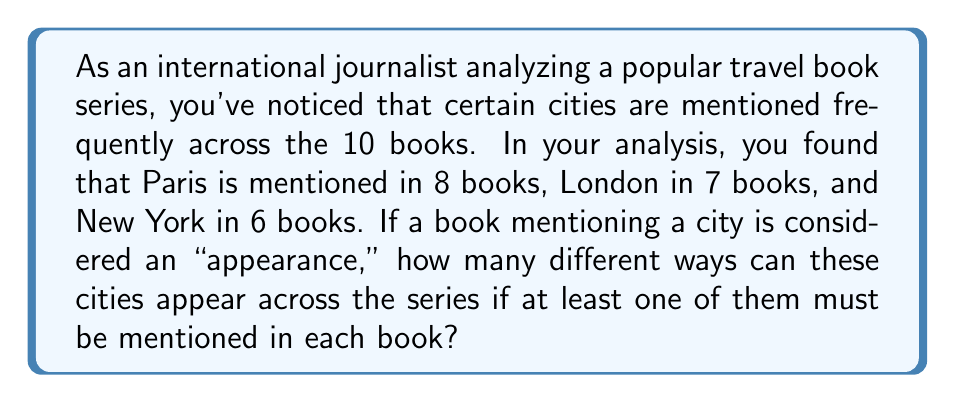Solve this math problem. Let's approach this step-by-step using the Inclusion-Exclusion Principle:

1) First, let's define our sets:
   P: Books mentioning Paris
   L: Books mentioning London
   N: Books mentioning New York

2) We want to find $|P \cup L \cup N|$, but we need to subtract the total number of books (10) from this to get the number of different ways the cities can appear.

3) Using the Inclusion-Exclusion Principle:

   $$|P \cup L \cup N| = |P| + |L| + |N| - |P \cap L| - |P \cap N| - |L \cap N| + |P \cap L \cap N|$$

4) We know $|P| = 8$, $|L| = 7$, and $|N| = 6$.

5) To find the intersections, we can use the complement method:
   $|P \cap L| = |P| + |L| - |P \cup L| = 8 + 7 - 10 = 5$
   $|P \cap N| = |P| + |N| - |P \cup N| = 8 + 6 - 10 = 4$
   $|L \cap N| = |L| + |N| - |L \cup N| = 7 + 6 - 10 = 3$

6) For $|P \cap L \cap N|$, we can use:
   $|P \cap L \cap N| = |P| + |L| + |N| - |P \cup L| - |P \cup N| - |L \cup N| + |P \cup L \cup N|$
   $= 8 + 7 + 6 - 10 - 10 - 10 + 10 = 1$

7) Now we can substitute these values:

   $$|P \cup L \cup N| = 8 + 7 + 6 - 5 - 4 - 3 + 1 = 10$$

8) The number of different ways the cities can appear is:
   $$2^{10} - 1 - (10 - 10) = 2^{10} - 1 = 1023$$

   We subtract 1 to exclude the case where no city is mentioned, and $(10 - 10) = 0$ represents the case where none of these three cities are mentioned in any book.
Answer: 1023 different ways 